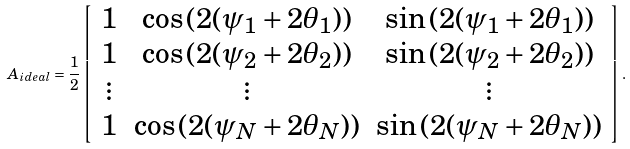Convert formula to latex. <formula><loc_0><loc_0><loc_500><loc_500>A _ { i d e a l } = \frac { 1 } { 2 } \left [ \begin{array} { c c c } 1 & \cos { ( 2 ( \psi _ { 1 } + 2 \theta _ { 1 } ) ) } & \sin { ( 2 ( \psi _ { 1 } + 2 \theta _ { 1 } ) ) } \\ 1 & \cos { ( 2 ( \psi _ { 2 } + 2 \theta _ { 2 } ) ) } & \sin { ( 2 ( \psi _ { 2 } + 2 \theta _ { 2 } ) ) } \\ \vdots & \vdots & \vdots \\ 1 & \cos { ( 2 ( \psi _ { N } + 2 \theta _ { N } ) ) } & \sin { ( 2 ( \psi _ { N } + 2 \theta _ { N } ) ) } \\ \end{array} \right ] .</formula> 